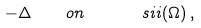Convert formula to latex. <formula><loc_0><loc_0><loc_500><loc_500>- \Delta \quad o n \quad \ \ s i i ( \Omega ) \, ,</formula> 